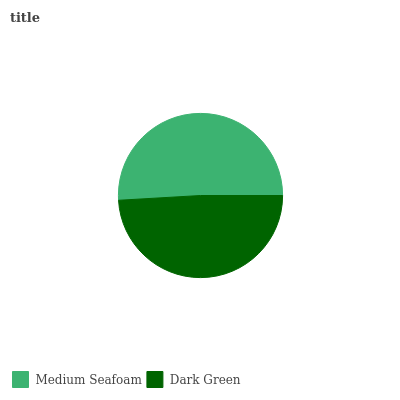Is Dark Green the minimum?
Answer yes or no. Yes. Is Medium Seafoam the maximum?
Answer yes or no. Yes. Is Dark Green the maximum?
Answer yes or no. No. Is Medium Seafoam greater than Dark Green?
Answer yes or no. Yes. Is Dark Green less than Medium Seafoam?
Answer yes or no. Yes. Is Dark Green greater than Medium Seafoam?
Answer yes or no. No. Is Medium Seafoam less than Dark Green?
Answer yes or no. No. Is Medium Seafoam the high median?
Answer yes or no. Yes. Is Dark Green the low median?
Answer yes or no. Yes. Is Dark Green the high median?
Answer yes or no. No. Is Medium Seafoam the low median?
Answer yes or no. No. 